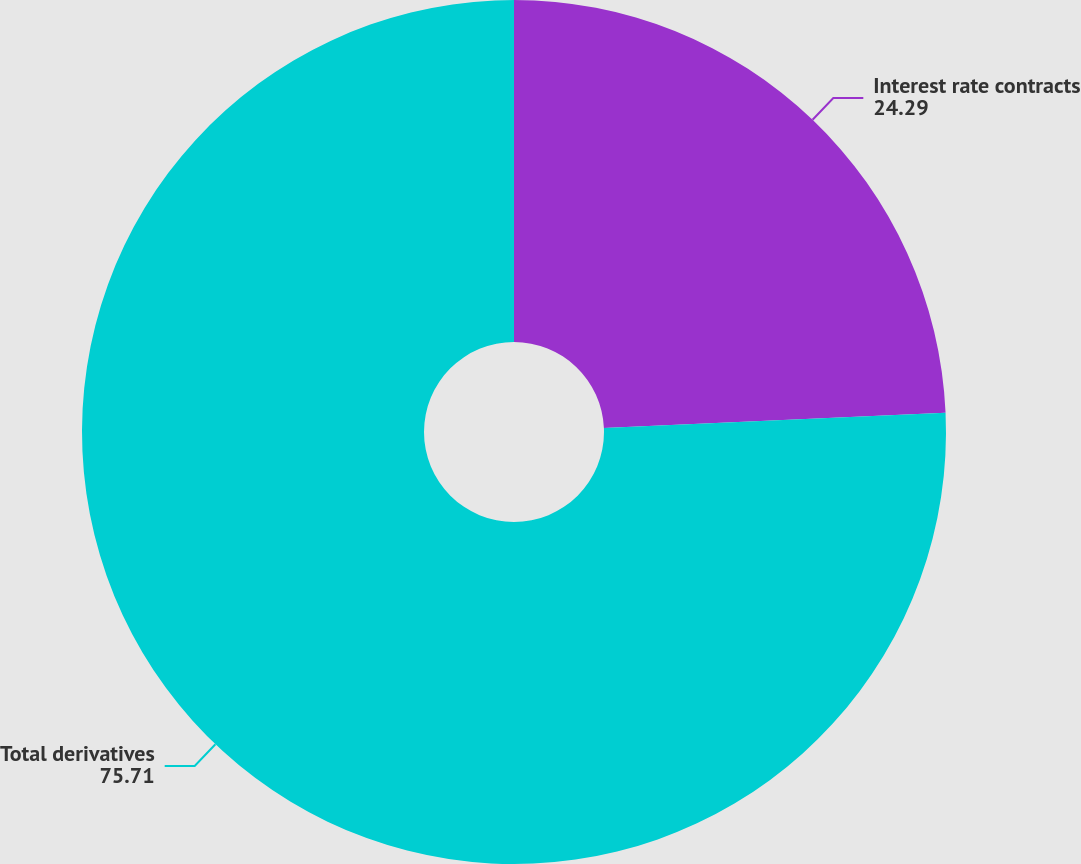Convert chart to OTSL. <chart><loc_0><loc_0><loc_500><loc_500><pie_chart><fcel>Interest rate contracts<fcel>Total derivatives<nl><fcel>24.29%<fcel>75.71%<nl></chart> 